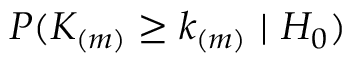<formula> <loc_0><loc_0><loc_500><loc_500>P ( K _ { ( m ) } \geq k _ { ( m ) } \ | \ H _ { 0 } )</formula> 